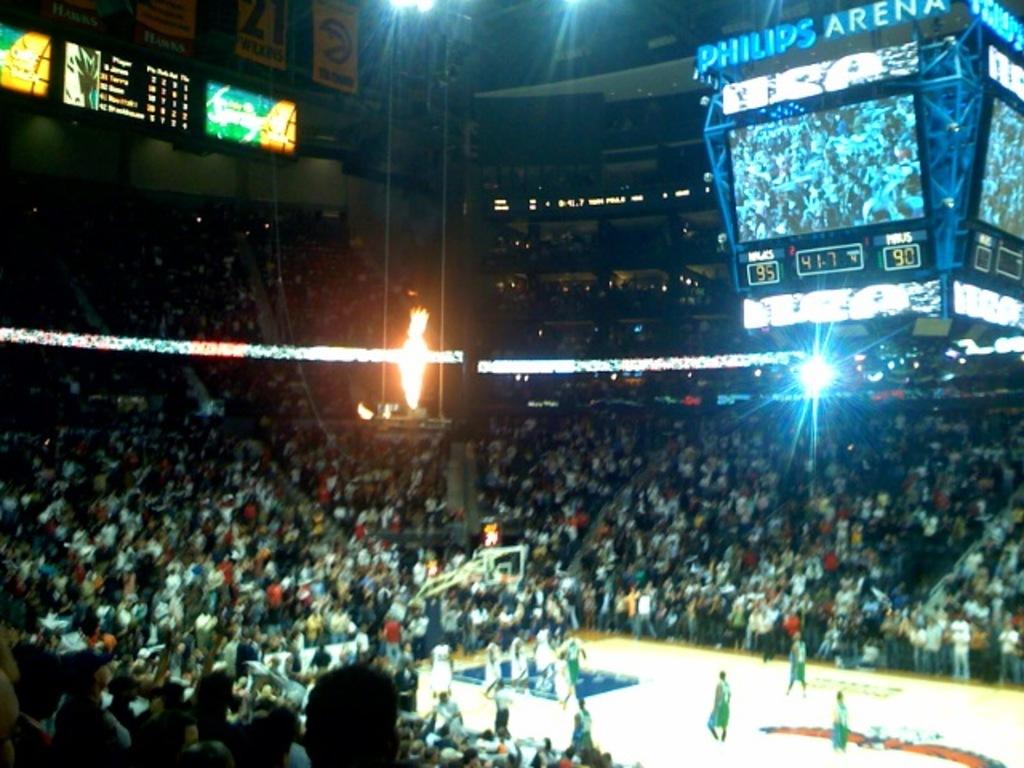What arena is this?
Provide a succinct answer. Philips arena. Does this game appear to be sold out?
Make the answer very short. Answering does not require reading text in the image. 